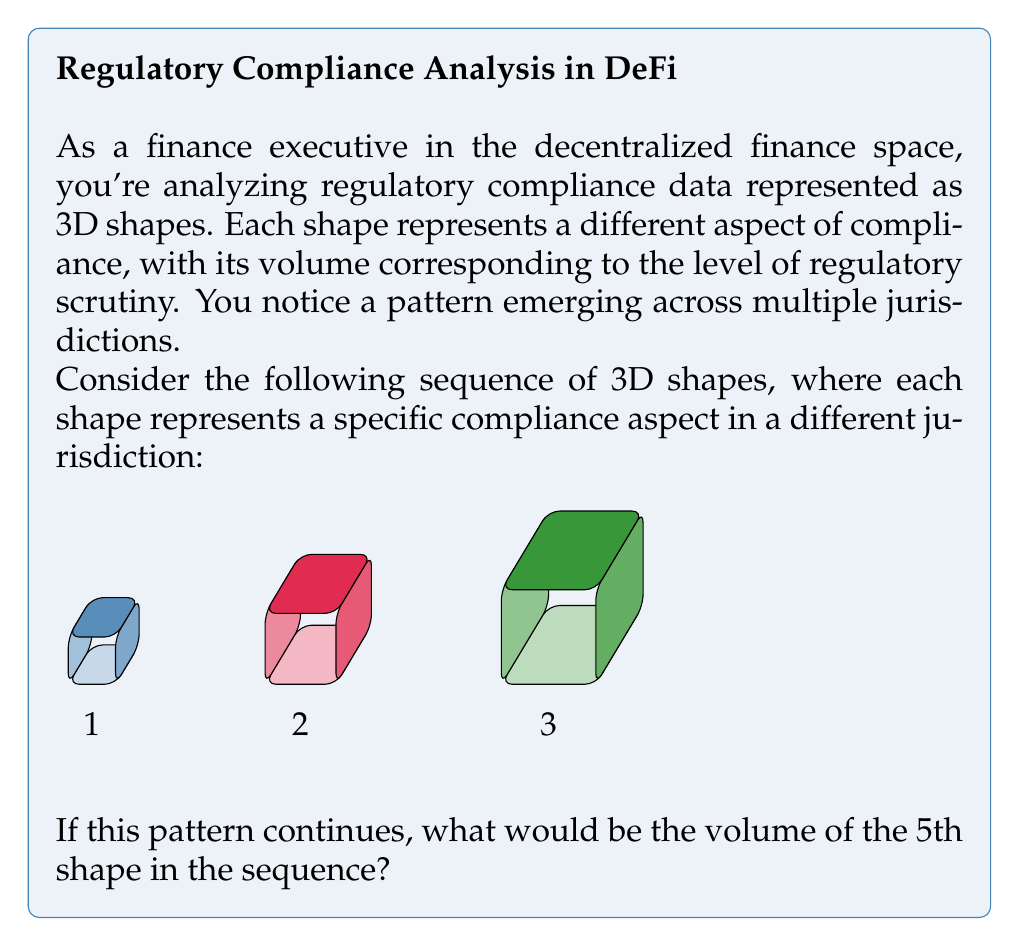Could you help me with this problem? Let's approach this step-by-step:

1) First, we need to identify the pattern in the sequence of shapes.

2) We can see that each shape is a cube, and they are increasing in size.

3) Let's calculate the volume of each cube:
   - Cube 1: $V_1 = 1^3 = 1$
   - Cube 2: $V_2 = 1.5^3 = 3.375$
   - Cube 3: $V_3 = 2^3 = 8$

4) Now, let's look at the scaling factor between each cube:
   - From Cube 1 to Cube 2: $1.5 / 1 = 1.5$
   - From Cube 2 to Cube 3: $2 / 1.5 = 1.333...$

5) We can see that the scaling factor is decreasing by 0.1666... (which is 1/6) each time.

6) So, we can predict the next scaling factors:
   - For Cube 4: $1.333... - 1/6 = 1.1666...$
   - For Cube 5: $1.1666... - 1/6 = 1$

7) Now we can calculate the side lengths:
   - Cube 4: $2 * 1.1666... = 2.333...$
   - Cube 5: $2.333... * 1 = 2.333...$

8) The volume of the 5th cube would be:
   $V_5 = (2.333...)^3 = 12.6851...$ ≈ 12.69
Answer: 12.69 